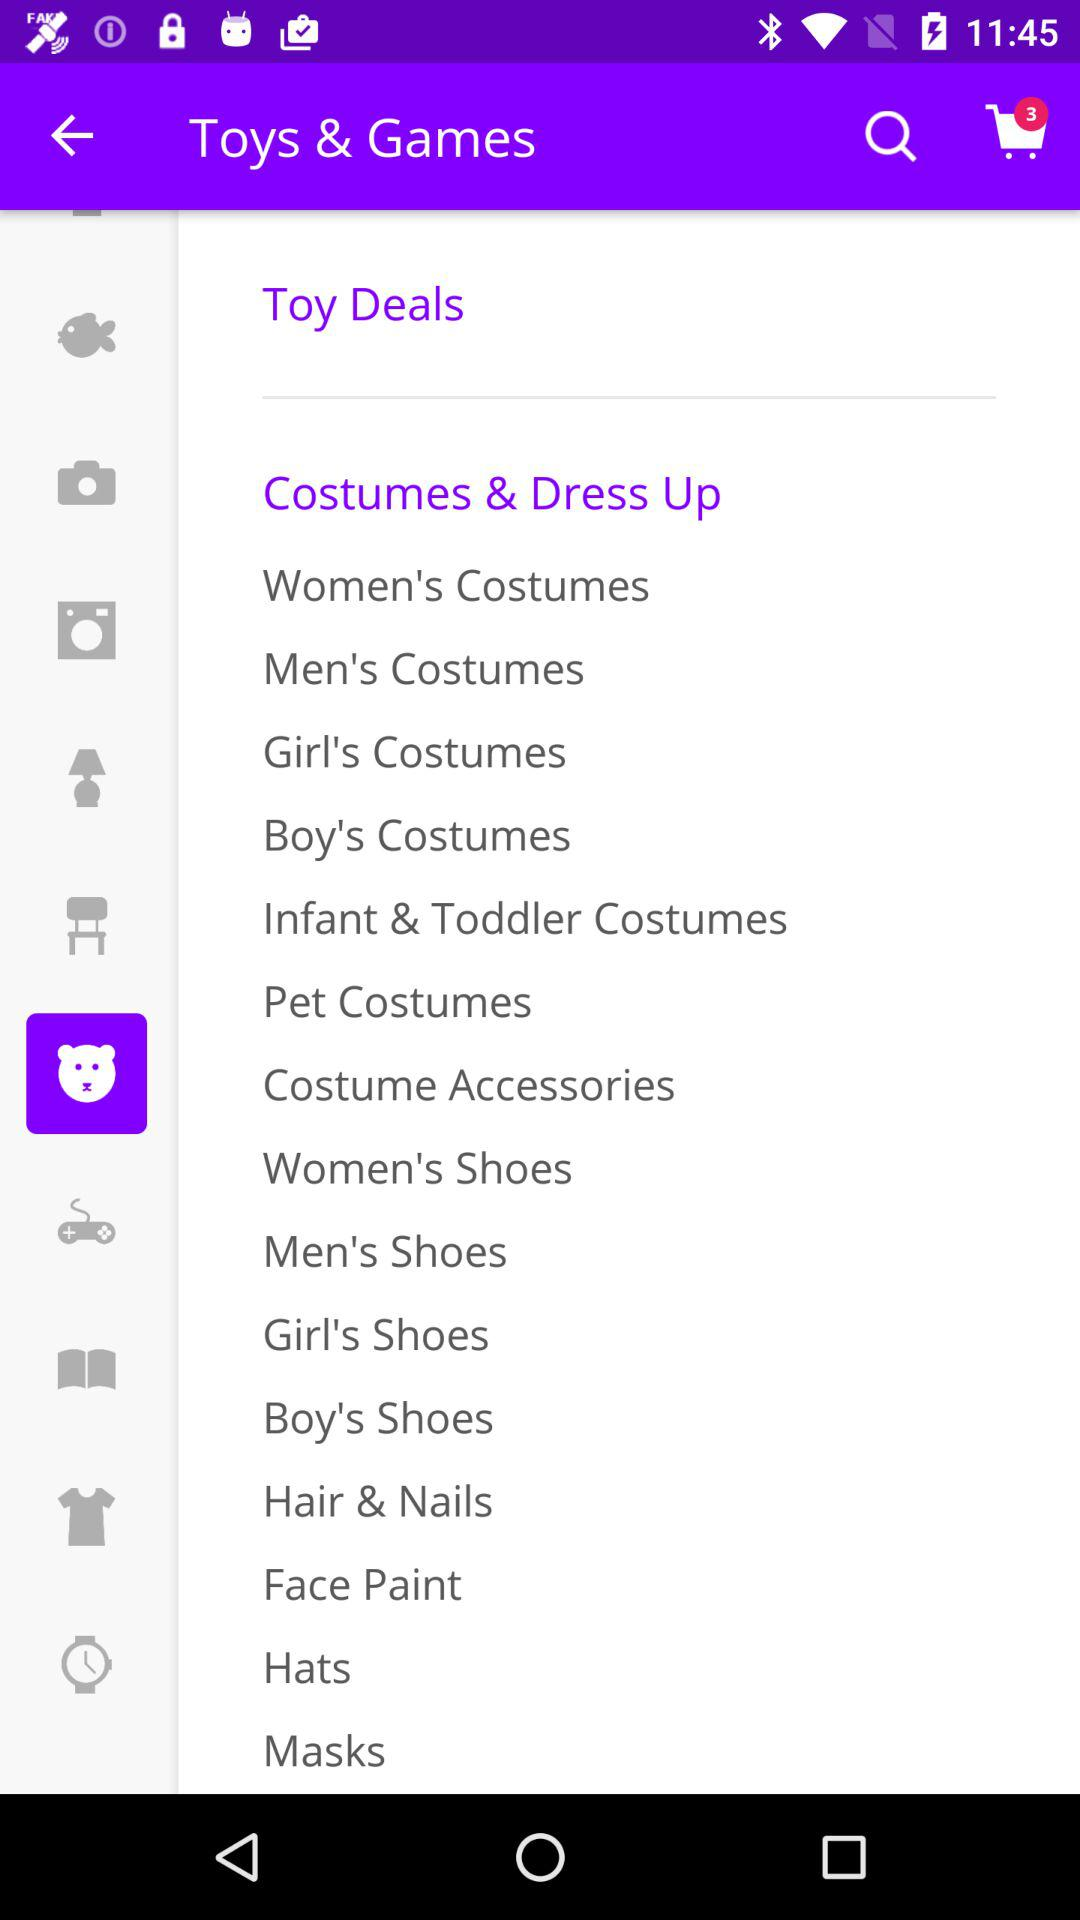How many items in total are there in the cart? There are 3 items in the cart. 